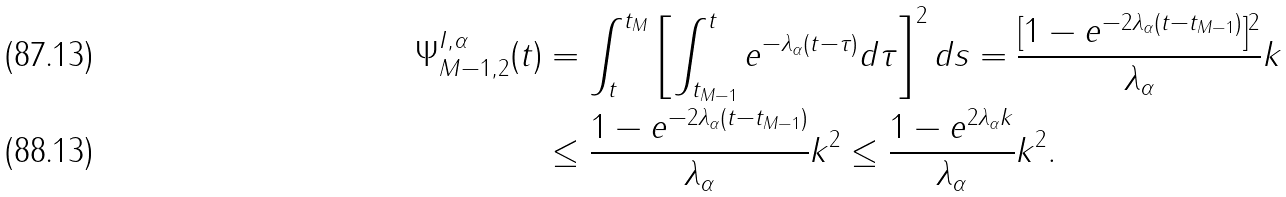<formula> <loc_0><loc_0><loc_500><loc_500>\Psi _ { M - 1 , 2 } ^ { I , \alpha } ( t ) & = \int _ { t } ^ { t _ { M } } \left [ \int _ { t _ { M - 1 } } ^ { t } e ^ { - \lambda _ { \alpha } ( t - \tau ) } d \tau \right ] ^ { 2 } d s = \frac { [ 1 - e ^ { - 2 \lambda _ { \alpha } ( t - t _ { M - 1 } ) } ] ^ { 2 } } { \lambda _ { \alpha } } k \\ & \leq \frac { 1 - e ^ { - 2 \lambda _ { \alpha } ( t - t _ { M - 1 } ) } } { \lambda _ { \alpha } } k ^ { 2 } \leq \frac { 1 - e ^ { 2 \lambda _ { \alpha } k } } { \lambda _ { \alpha } } k ^ { 2 } .</formula> 